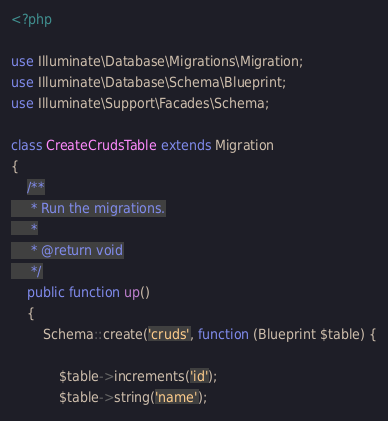Convert code to text. <code><loc_0><loc_0><loc_500><loc_500><_PHP_><?php

use Illuminate\Database\Migrations\Migration;
use Illuminate\Database\Schema\Blueprint;
use Illuminate\Support\Facades\Schema;

class CreateCrudsTable extends Migration
{
    /**
     * Run the migrations.
     *
     * @return void
     */
    public function up()
    {
        Schema::create('cruds', function (Blueprint $table) {
            
            $table->increments('id');
            $table->string('name');</code> 